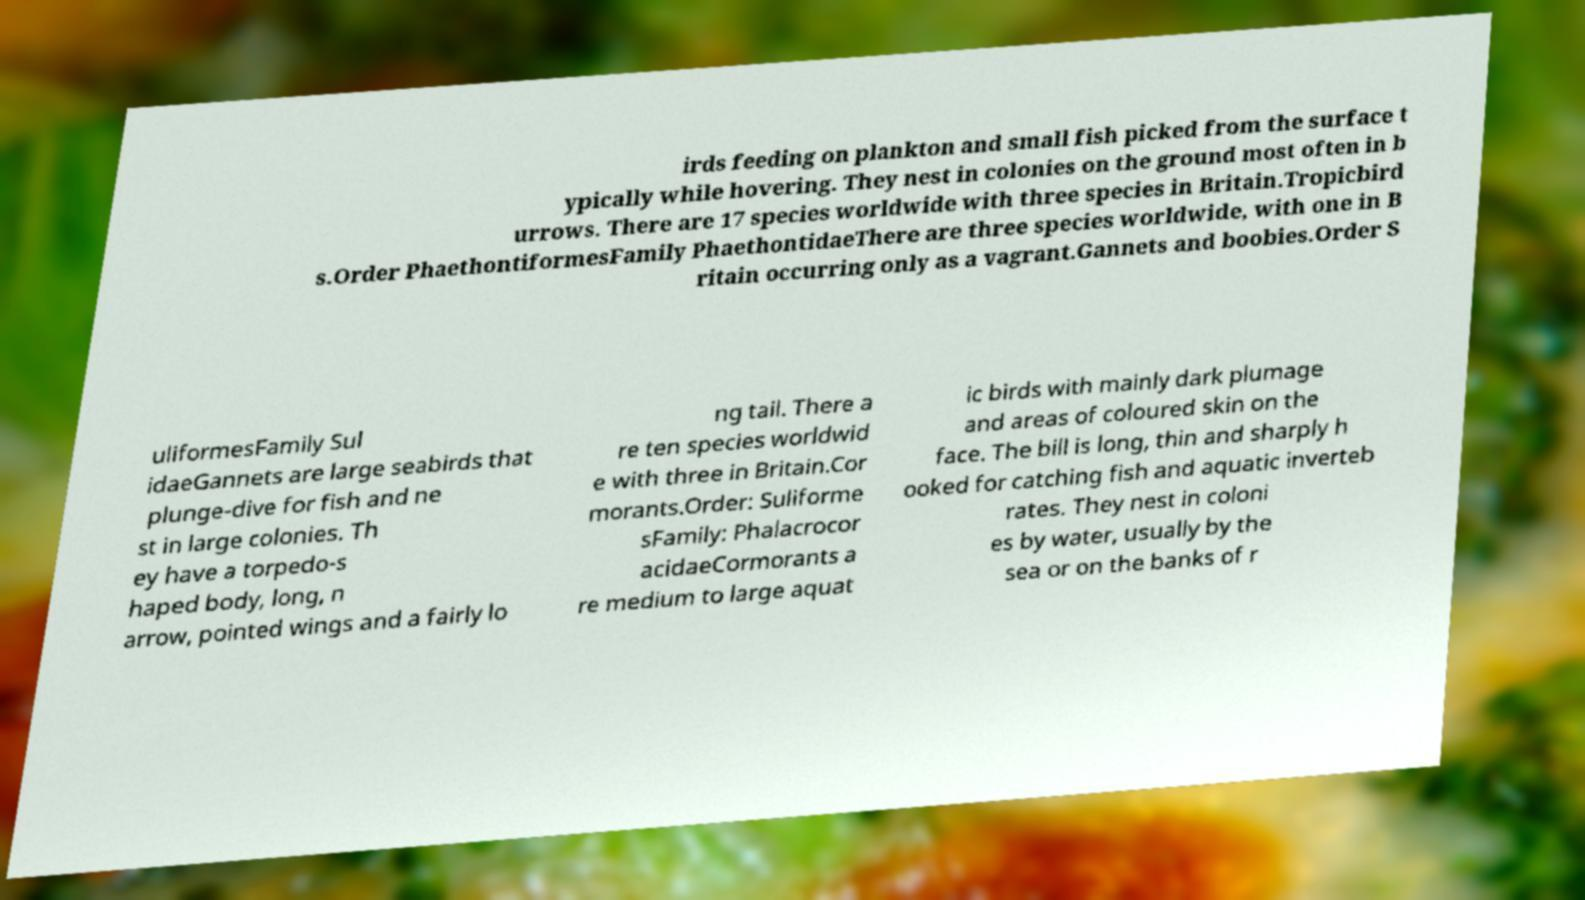Could you extract and type out the text from this image? irds feeding on plankton and small fish picked from the surface t ypically while hovering. They nest in colonies on the ground most often in b urrows. There are 17 species worldwide with three species in Britain.Tropicbird s.Order PhaethontiformesFamily PhaethontidaeThere are three species worldwide, with one in B ritain occurring only as a vagrant.Gannets and boobies.Order S uliformesFamily Sul idaeGannets are large seabirds that plunge-dive for fish and ne st in large colonies. Th ey have a torpedo-s haped body, long, n arrow, pointed wings and a fairly lo ng tail. There a re ten species worldwid e with three in Britain.Cor morants.Order: Suliforme sFamily: Phalacrocor acidaeCormorants a re medium to large aquat ic birds with mainly dark plumage and areas of coloured skin on the face. The bill is long, thin and sharply h ooked for catching fish and aquatic inverteb rates. They nest in coloni es by water, usually by the sea or on the banks of r 